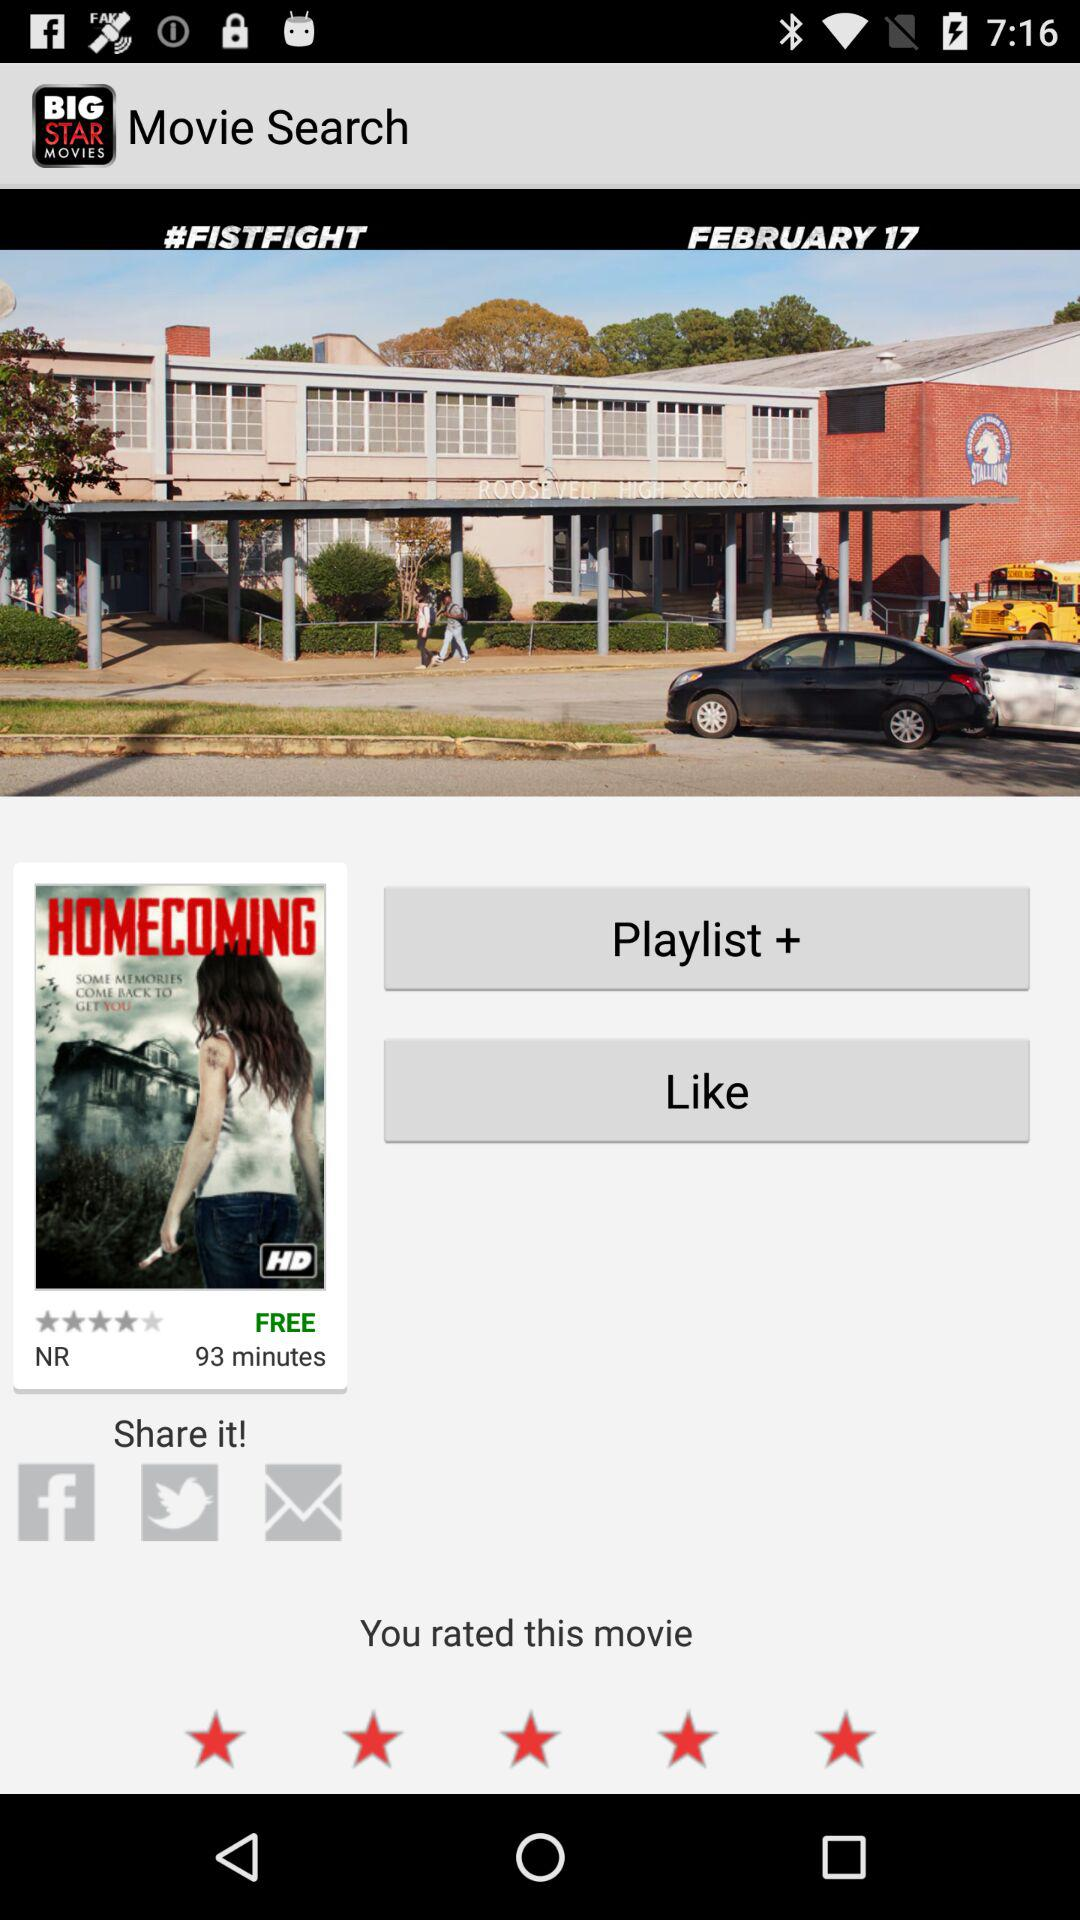How long is the "HOMECOMING" movie? The "HOMECOMING" movie is 93 minutes long. 